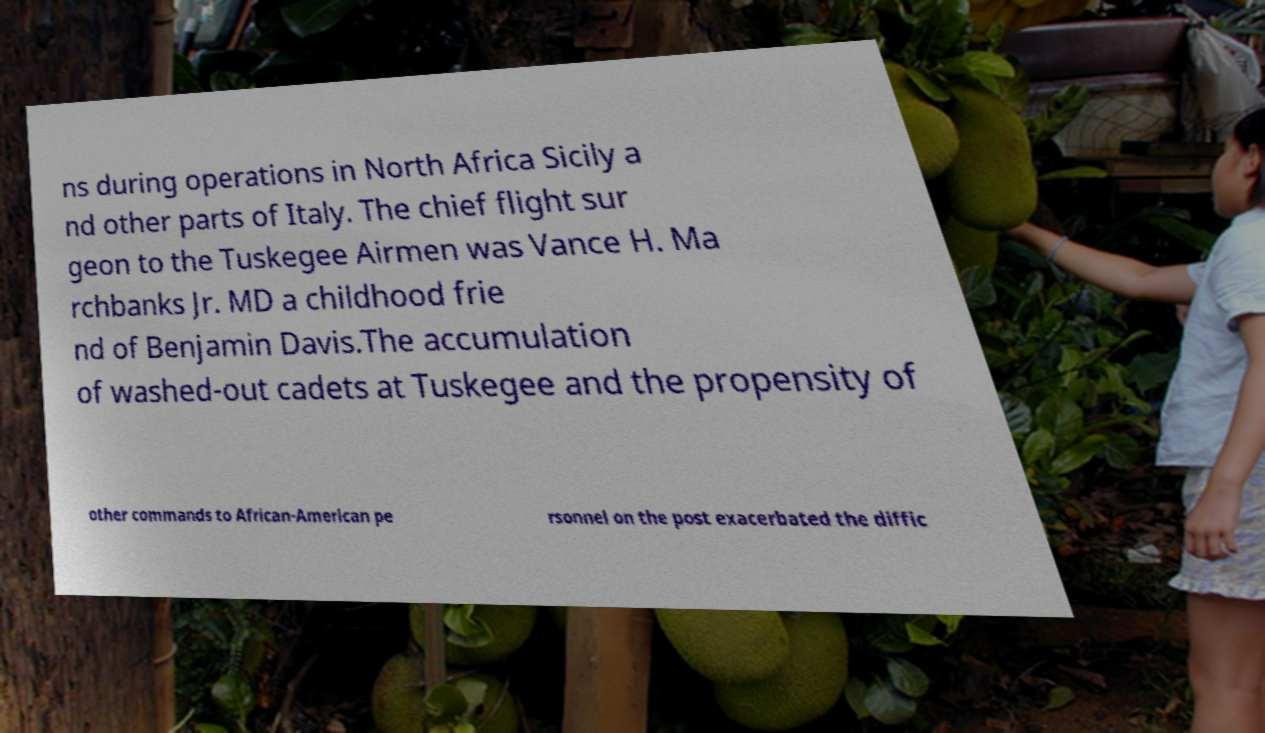What messages or text are displayed in this image? I need them in a readable, typed format. ns during operations in North Africa Sicily a nd other parts of Italy. The chief flight sur geon to the Tuskegee Airmen was Vance H. Ma rchbanks Jr. MD a childhood frie nd of Benjamin Davis.The accumulation of washed-out cadets at Tuskegee and the propensity of other commands to African-American pe rsonnel on the post exacerbated the diffic 